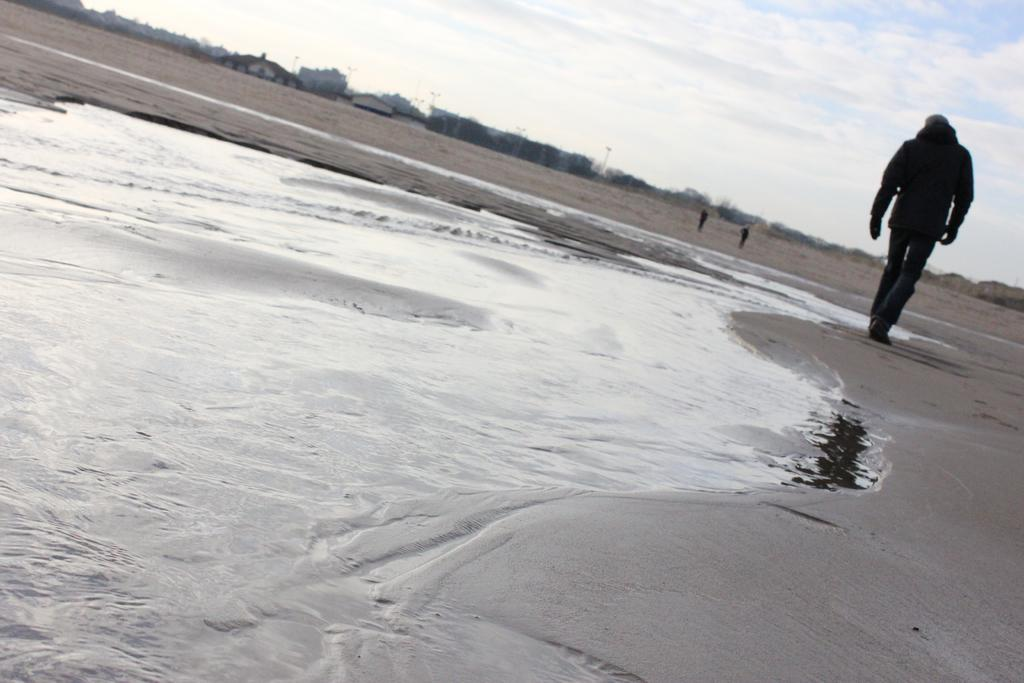Where was the image taken? The image was taken at a beach. What is the person in the image doing? There is a person walking in the image. What can be seen in the background of the image? There are houses visible in the background of the image. How many people are in the background of the image? There are two persons in the background of the image. What is visible in the sky in the image? The sky is visible in the image, and clouds are present. Can you see any fish swimming in the water in the image? There is no water visible in the image, so it is not possible to see any fish swimming. What type of yoke is being used by the person walking in the image? There is no yoke present in the image; the person is simply walking. 